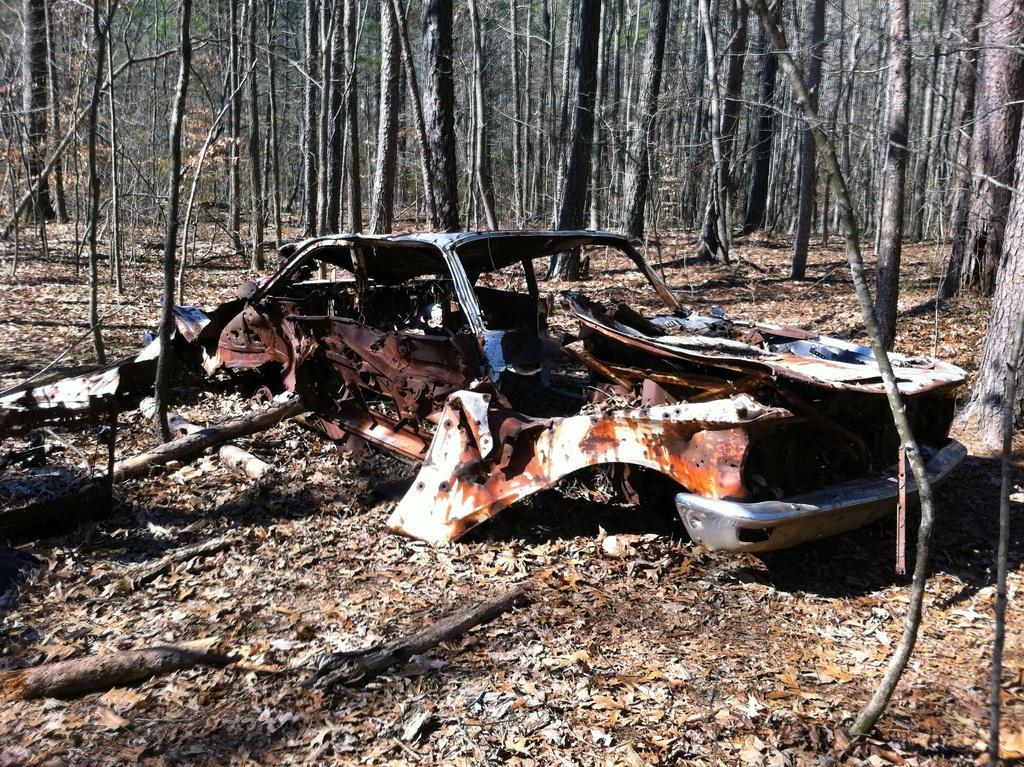In one or two sentences, can you explain what this image depicts? This image is taken outdoors. At the bottom of the image there is a ground with dry leaves and barks on it. In the background there are many trees. In the middle of the image there is a car crash on the ground. 